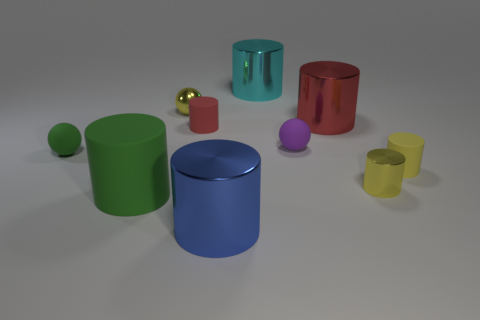Subtract all large red cylinders. How many cylinders are left? 6 Subtract 2 cylinders. How many cylinders are left? 5 Subtract all cyan cylinders. How many cylinders are left? 6 Subtract all cylinders. How many objects are left? 3 Subtract all large green rubber cylinders. Subtract all large blue metal cylinders. How many objects are left? 8 Add 4 large red cylinders. How many large red cylinders are left? 5 Add 6 large metal things. How many large metal things exist? 9 Subtract 0 blue blocks. How many objects are left? 10 Subtract all yellow spheres. Subtract all purple blocks. How many spheres are left? 2 Subtract all brown spheres. How many red cylinders are left? 2 